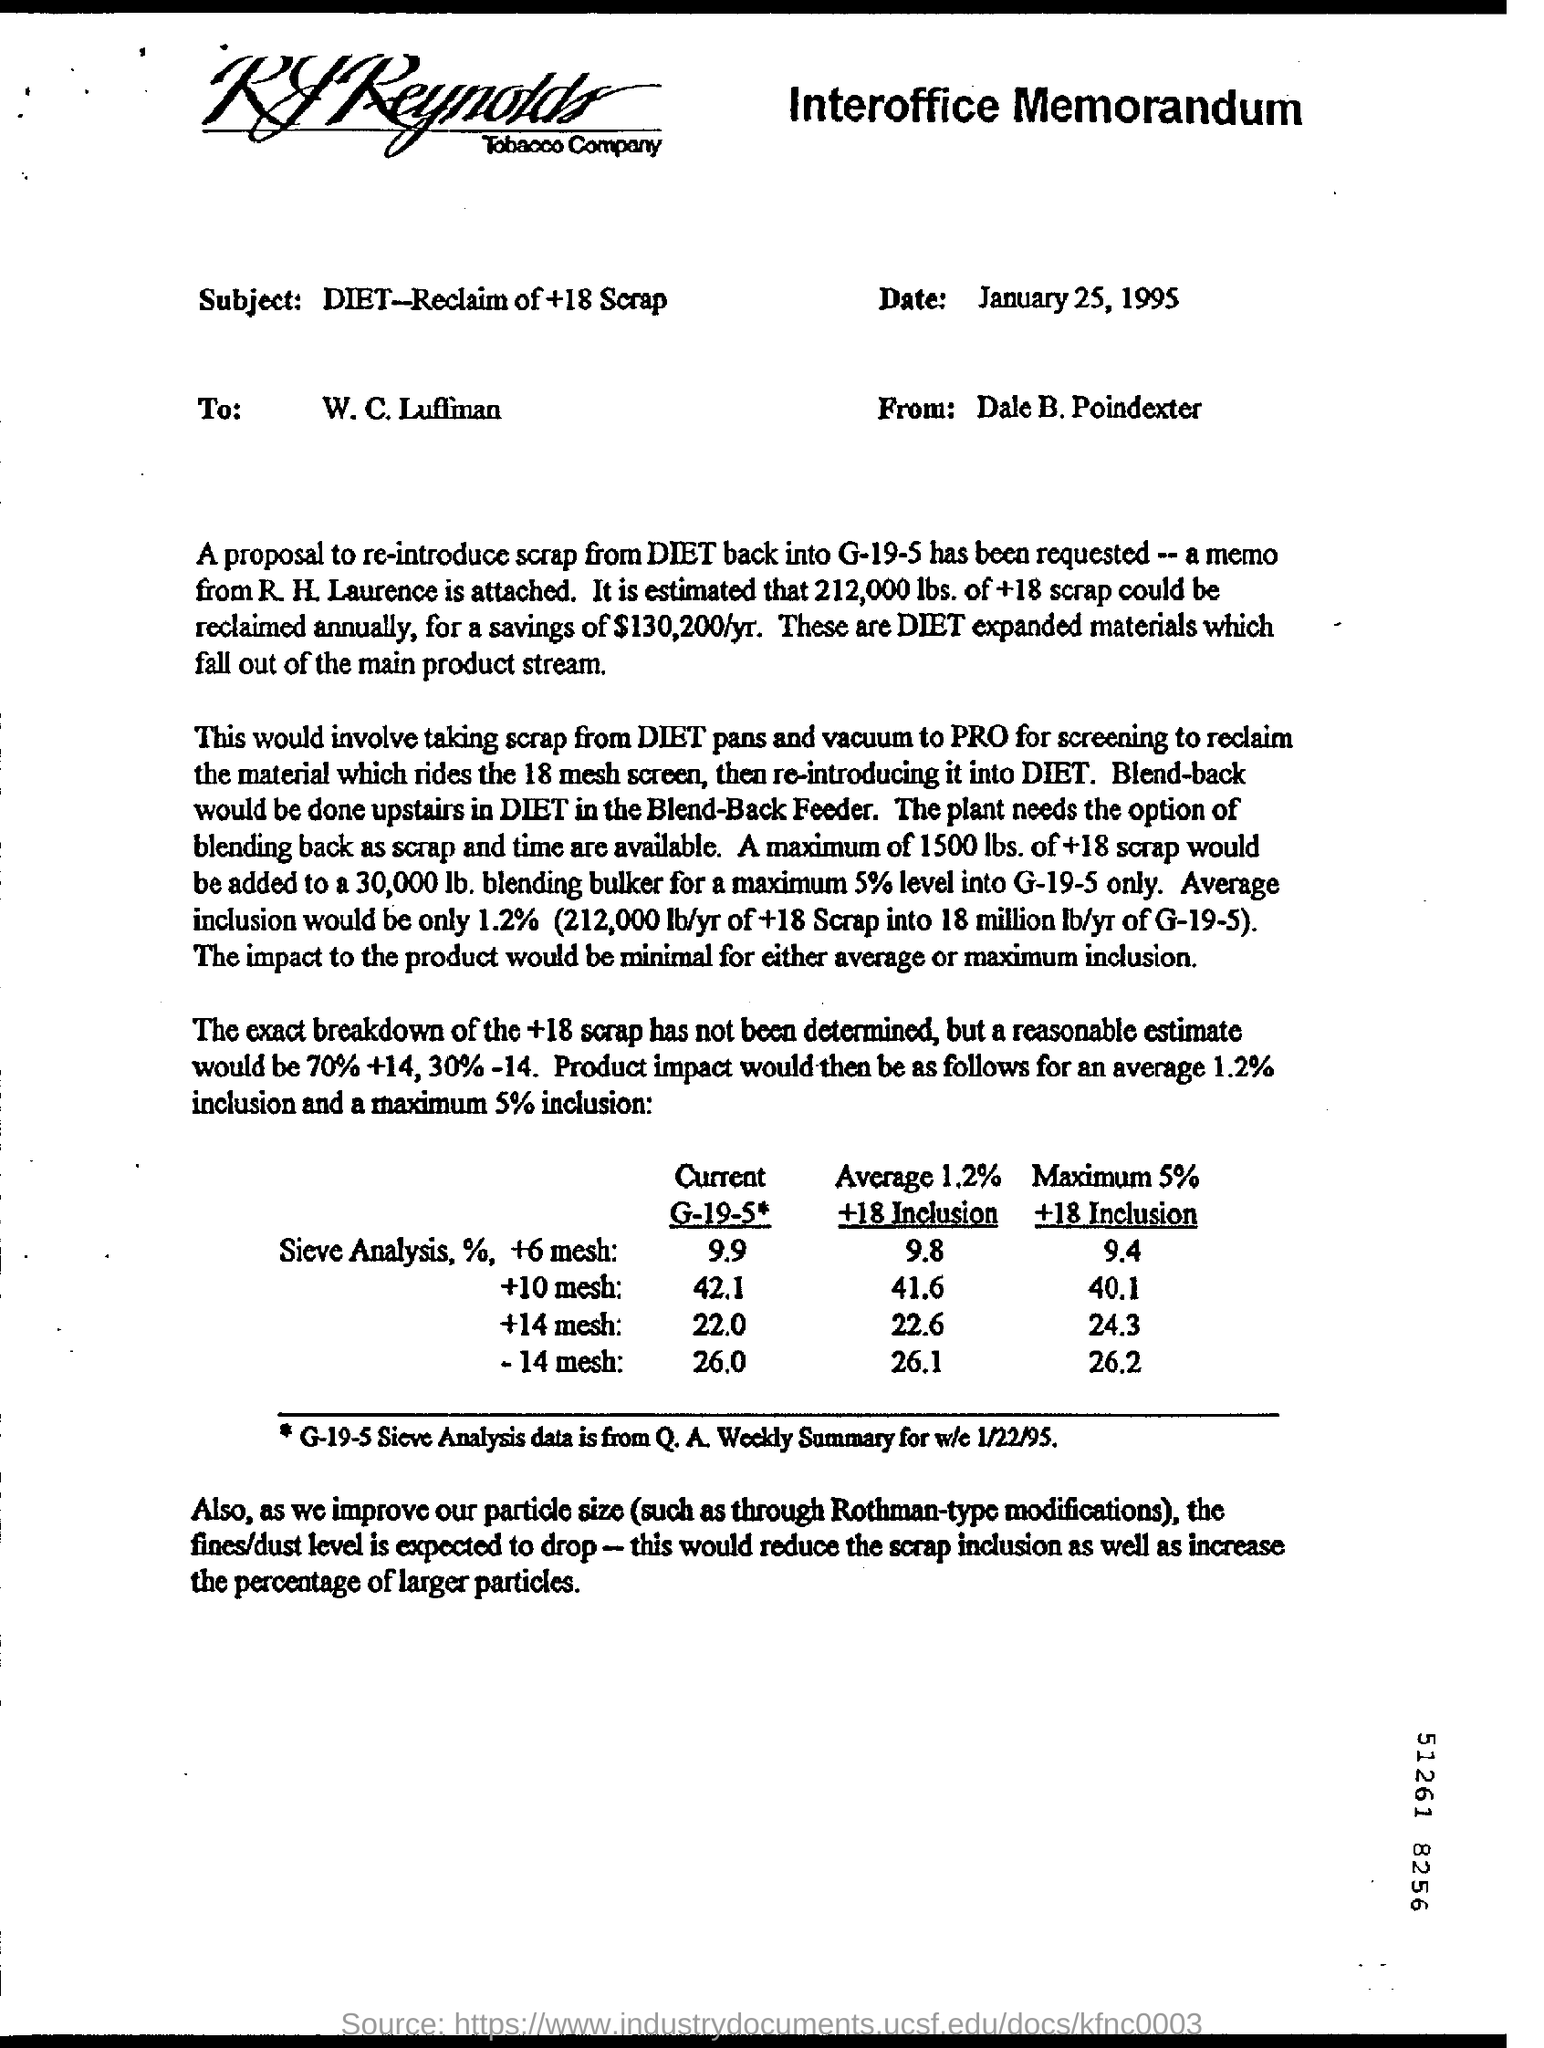What kind of communication is this?
Your answer should be compact. Interoffice Memorandum. What is the subject of interoffice memorandum ?
Your response must be concise. DIET - reclam of+18 scrap. From where G-19-5 Sieve Analysis data taken  ?
Keep it short and to the point. Q.A. Weekly summary. What is the proposal ?
Give a very brief answer. To reintroduce scrap from DIET back into G-19-5. 